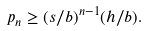<formula> <loc_0><loc_0><loc_500><loc_500>p _ { n } \geq ( s / b ) ^ { n - 1 } ( h / b ) .</formula> 